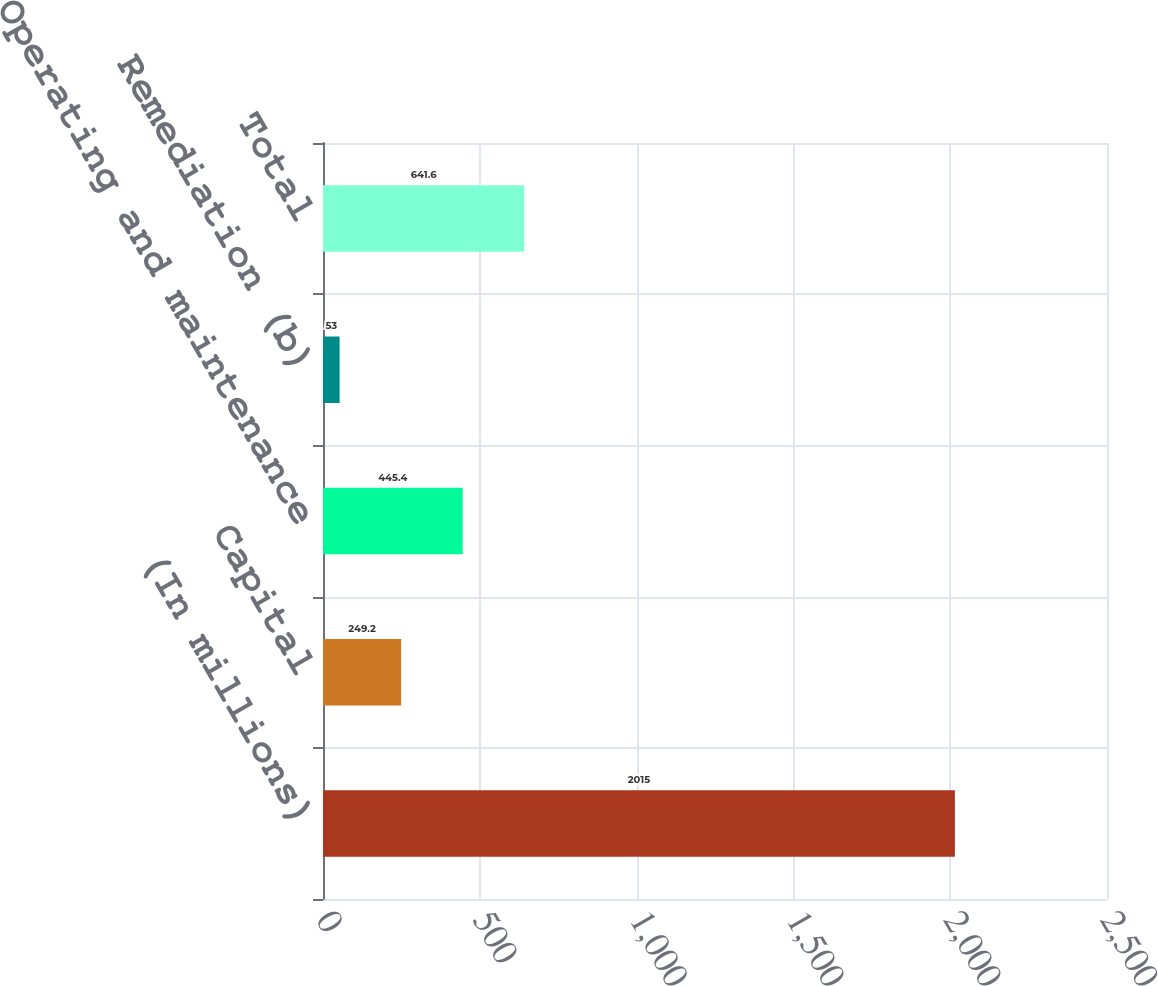Convert chart. <chart><loc_0><loc_0><loc_500><loc_500><bar_chart><fcel>(In millions)<fcel>Capital<fcel>Operating and maintenance<fcel>Remediation (b)<fcel>Total<nl><fcel>2015<fcel>249.2<fcel>445.4<fcel>53<fcel>641.6<nl></chart> 